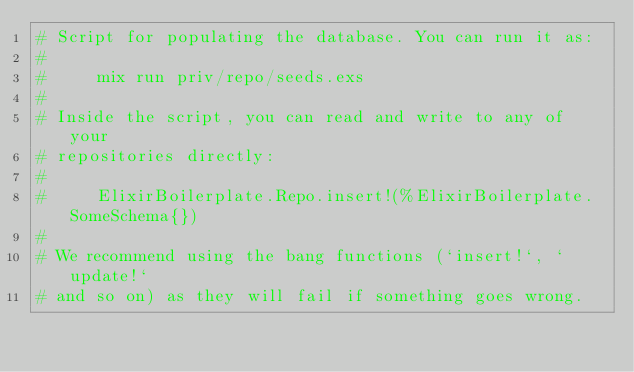Convert code to text. <code><loc_0><loc_0><loc_500><loc_500><_Elixir_># Script for populating the database. You can run it as:
#
#     mix run priv/repo/seeds.exs
#
# Inside the script, you can read and write to any of your
# repositories directly:
#
#     ElixirBoilerplate.Repo.insert!(%ElixirBoilerplate.SomeSchema{})
#
# We recommend using the bang functions (`insert!`, `update!`
# and so on) as they will fail if something goes wrong.
</code> 